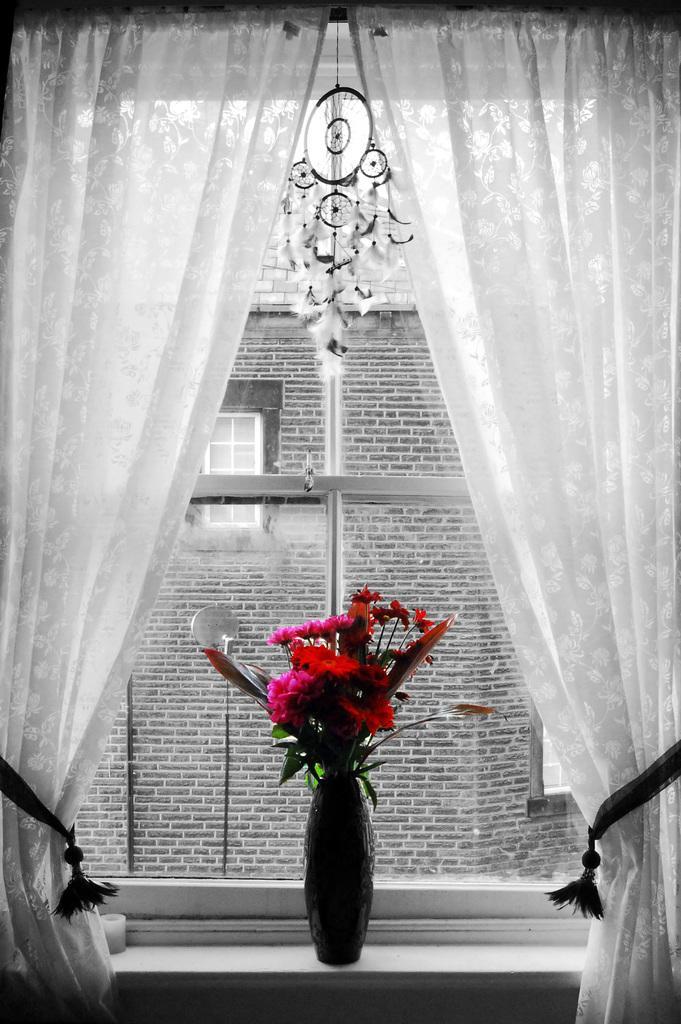Can you describe this image briefly? This image consists of a flower vase. In which there are red color flowers. It is kept in a window. we can see white color curtains. In the background, there is a building. 